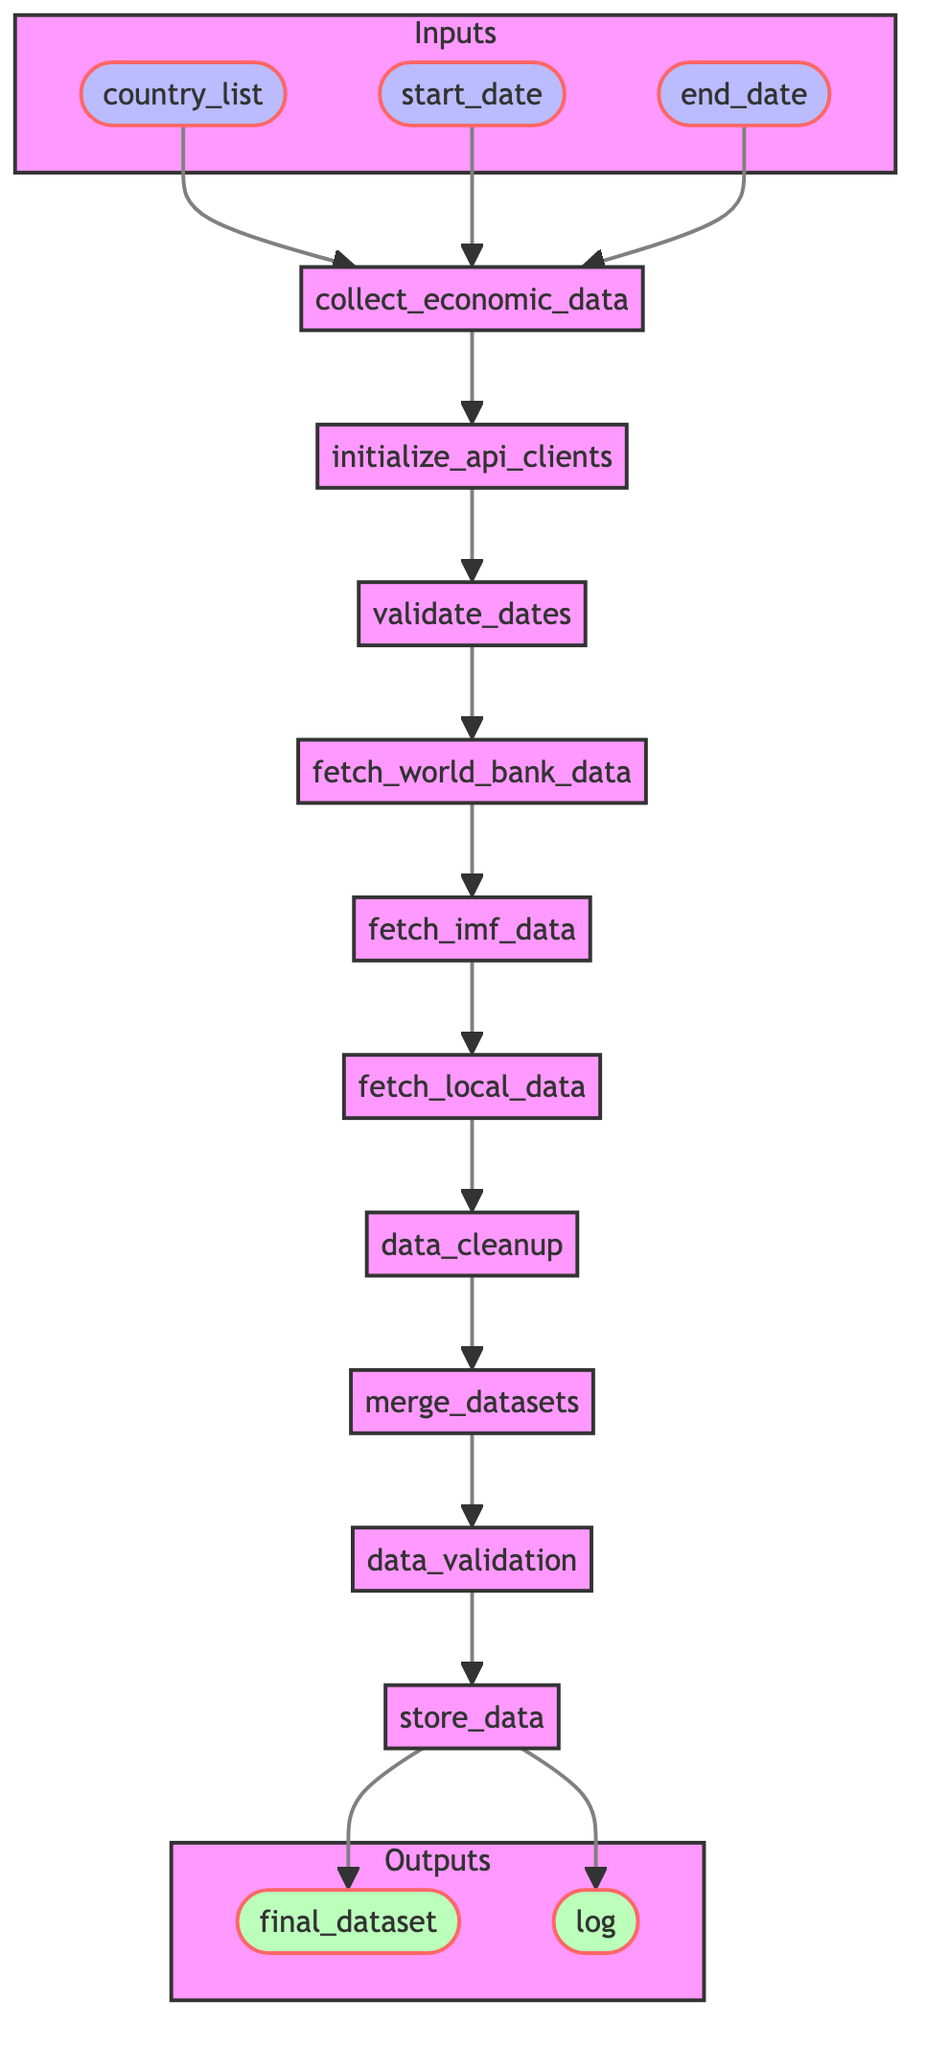What is the function name in this diagram? The function name is represented at the start of the flowchart, labeled as "collect_economic_data."
Answer: collect_economic_data How many steps are there in the process? By counting the nodes in the main flow of the diagram, there are nine steps depicted in the sequence from initialize API clients to store data.
Answer: 9 What is the first step in the process? The first step is shown as the node immediately following the function name, which is "initialize_api_clients."
Answer: initialize_api_clients Which node comes after "data_cleanup"? In the flowchart, the node that follows "data_cleanup" is "merge_datasets."
Answer: merge_datasets What inputs are required for the function? The required inputs are listed in the input nodes connected to the function name, which are "country_list," "start_date," and "end_date."
Answer: country_list, start_date, end_date What are the outputs of this function? The outputs are represented in the diagram as two nodes at the end of the flow: "final_dataset" and "log."
Answer: final_dataset, log How many data fetching steps are in the pipeline? There are three distinct nodes labeled for fetching data from various sources: "fetch_world_bank_data," "fetch_imf_data," and "fetch_local_data," making a total of three data fetching steps.
Answer: 3 What is the purpose of the "data_validation" step? The purpose of the "data_validation" step is to ensure the accuracy and completeness of the collected data before final storage.
Answer: Ensure data accuracy and completeness What is the last step taken before storing the data? The last step taken before the data is stored is the "data_validation" step, which precedes the "store_data" node.
Answer: data_validation 